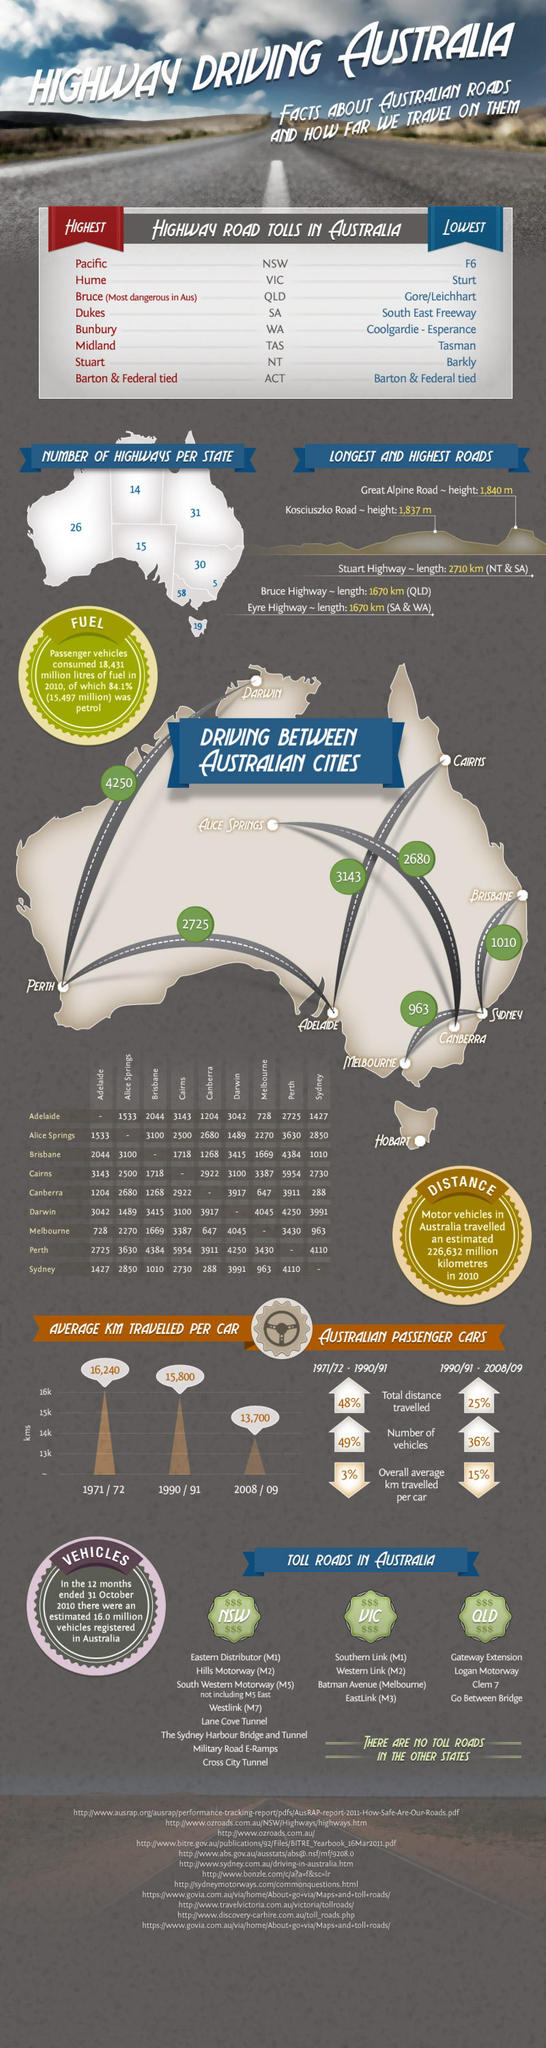Specify some key components in this picture. The Eyre Highway is the longest highway that falls within the regions of South and Western Australia. The longest distance in kilometers between two cities in Australia is 5,954 kilometers. There are 58 highways in the state or province of Victoria. New South Wales has the most number of toll roads, according to the information provided. There are currently 19 highways in the state or province of Tasmania. 